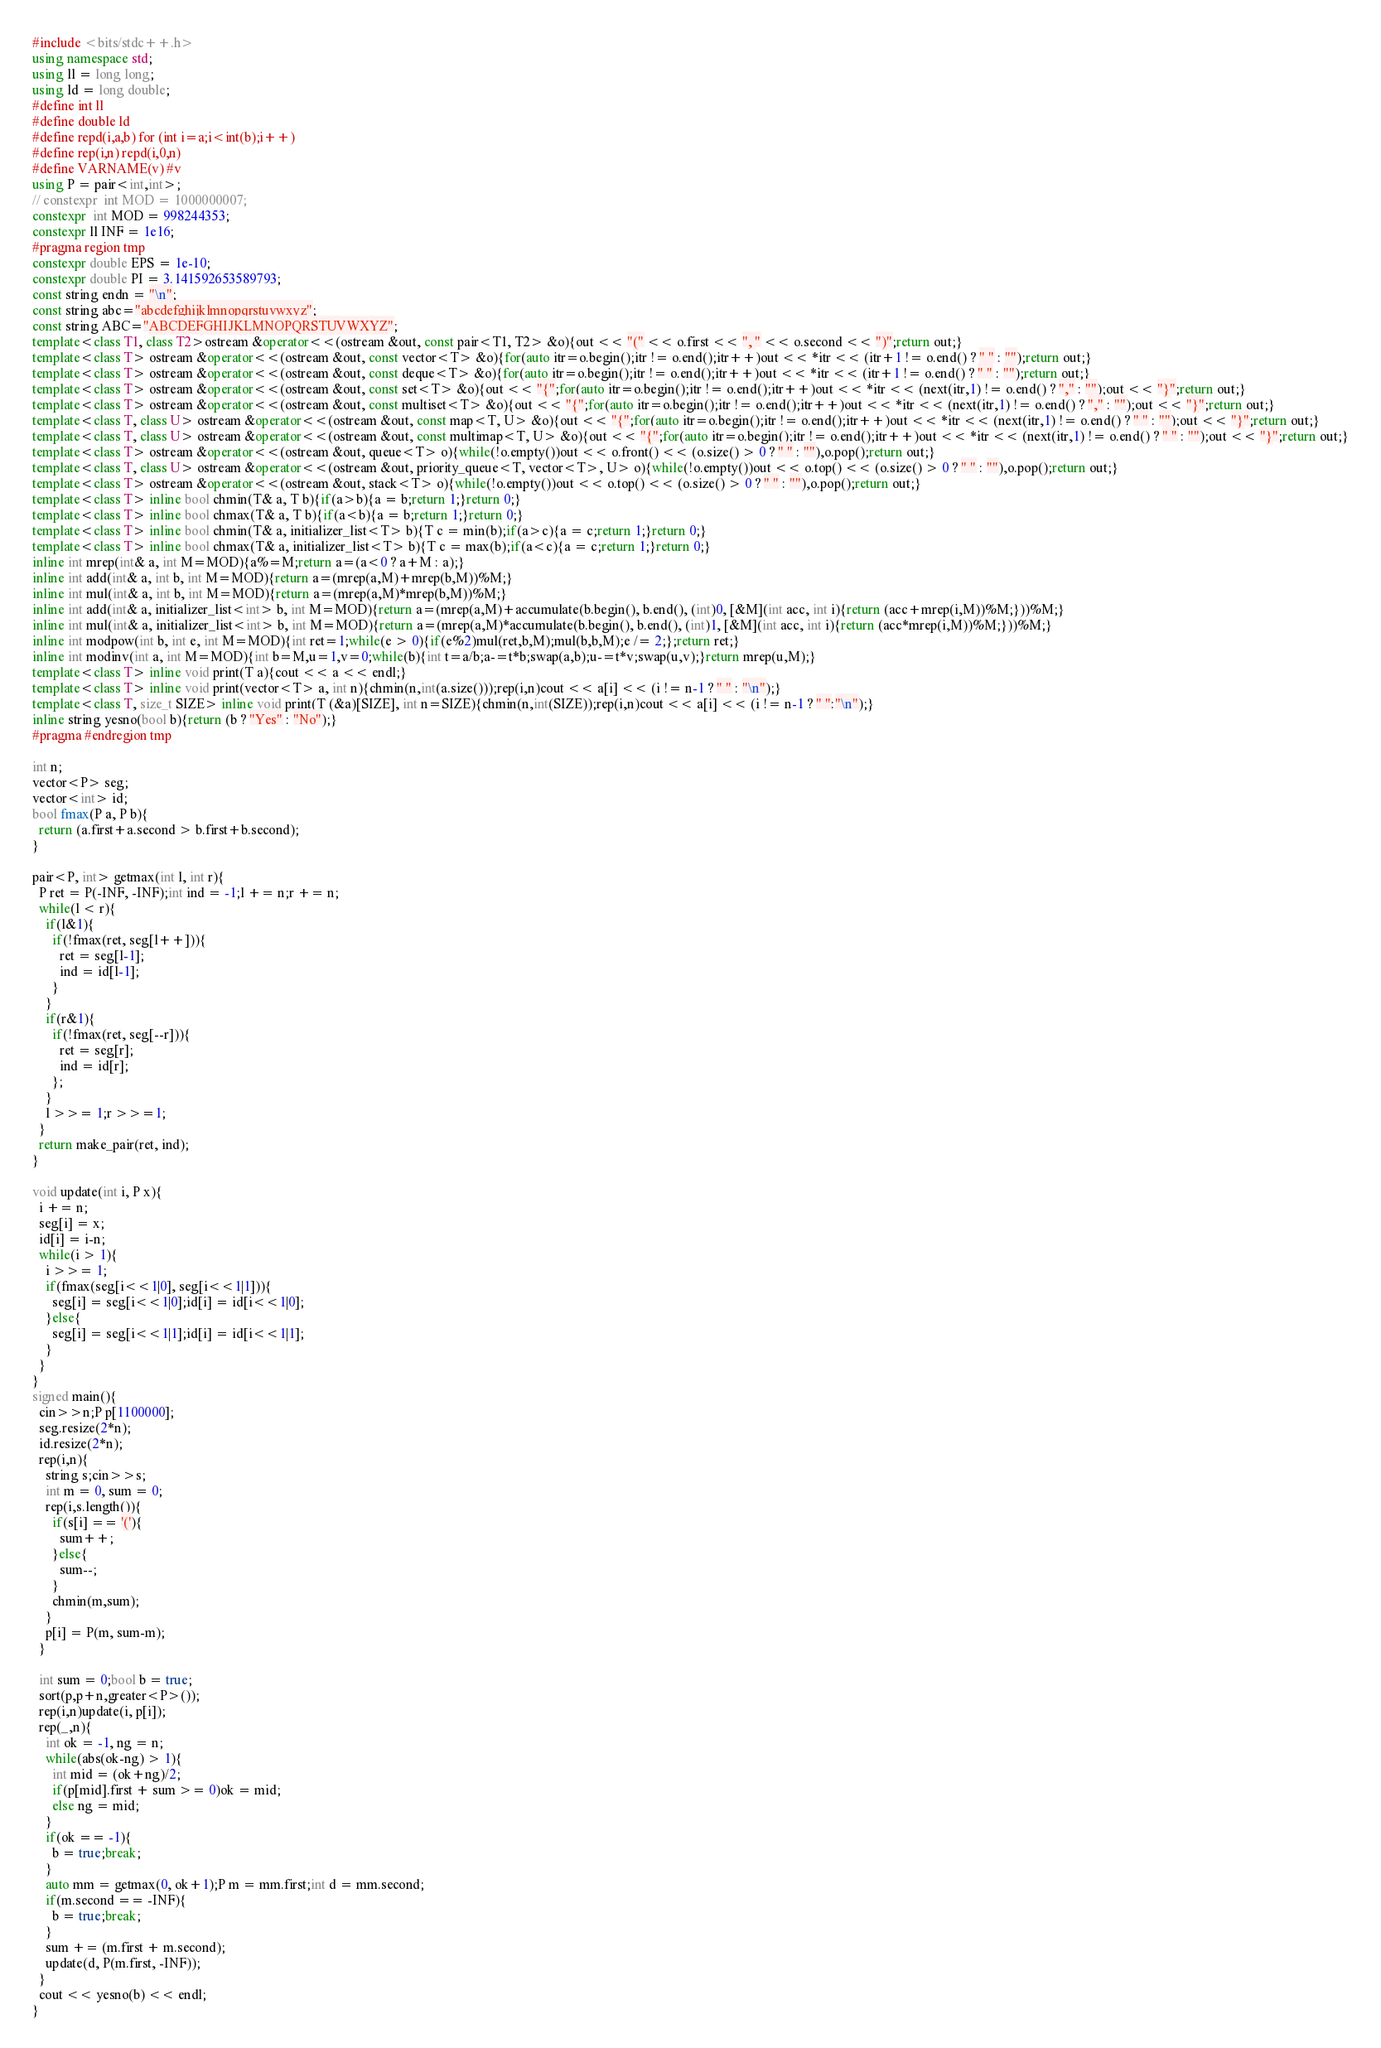<code> <loc_0><loc_0><loc_500><loc_500><_C++_>#include <bits/stdc++.h>
using namespace std;
using ll = long long;
using ld = long double;
#define int ll
#define double ld
#define repd(i,a,b) for (int i=a;i<int(b);i++)
#define rep(i,n) repd(i,0,n)
#define VARNAME(v) #v
using P = pair<int,int>;
// constexpr  int MOD = 1000000007;
constexpr  int MOD = 998244353;
constexpr ll INF = 1e16;
#pragma region tmp
constexpr double EPS = 1e-10;
constexpr double PI = 3.141592653589793;
const string endn = "\n";
const string abc="abcdefghijklmnopqrstuvwxyz";
const string ABC="ABCDEFGHIJKLMNOPQRSTUVWXYZ";
template<class T1, class T2>ostream &operator<<(ostream &out, const pair<T1, T2> &o){out << "(" << o.first << ", " << o.second << ")";return out;}
template<class T> ostream &operator<<(ostream &out, const vector<T> &o){for(auto itr=o.begin();itr != o.end();itr++)out << *itr << (itr+1 != o.end() ? " " : "");return out;}
template<class T> ostream &operator<<(ostream &out, const deque<T> &o){for(auto itr=o.begin();itr != o.end();itr++)out << *itr << (itr+1 != o.end() ? " " : "");return out;}
template<class T> ostream &operator<<(ostream &out, const set<T> &o){out << "{";for(auto itr=o.begin();itr != o.end();itr++)out << *itr << (next(itr,1) != o.end() ? "," : "");out << "}";return out;}
template<class T> ostream &operator<<(ostream &out, const multiset<T> &o){out << "{";for(auto itr=o.begin();itr != o.end();itr++)out << *itr << (next(itr,1) != o.end() ? "," : "");out << "}";return out;}
template<class T, class U> ostream &operator<<(ostream &out, const map<T, U> &o){out << "{";for(auto itr=o.begin();itr != o.end();itr++)out << *itr << (next(itr,1) != o.end() ? " " : "");out << "}";return out;}
template<class T, class U> ostream &operator<<(ostream &out, const multimap<T, U> &o){out << "{";for(auto itr=o.begin();itr != o.end();itr++)out << *itr << (next(itr,1) != o.end() ? " " : "");out << "}";return out;}
template<class T> ostream &operator<<(ostream &out, queue<T> o){while(!o.empty())out << o.front() << (o.size() > 0 ? " " : ""),o.pop();return out;}
template<class T, class U> ostream &operator<<(ostream &out, priority_queue<T, vector<T>, U> o){while(!o.empty())out << o.top() << (o.size() > 0 ? " " : ""),o.pop();return out;}
template<class T> ostream &operator<<(ostream &out, stack<T> o){while(!o.empty())out << o.top() << (o.size() > 0 ? " " : ""),o.pop();return out;}
template<class T> inline bool chmin(T& a, T b){if(a>b){a = b;return 1;}return 0;}
template<class T> inline bool chmax(T& a, T b){if(a<b){a = b;return 1;}return 0;}
template<class T> inline bool chmin(T& a, initializer_list<T> b){T c = min(b);if(a>c){a = c;return 1;}return 0;}
template<class T> inline bool chmax(T& a, initializer_list<T> b){T c = max(b);if(a<c){a = c;return 1;}return 0;}
inline int mrep(int& a, int M=MOD){a%=M;return a=(a<0 ? a+M : a);}
inline int add(int& a, int b, int M=MOD){return a=(mrep(a,M)+mrep(b,M))%M;}
inline int mul(int& a, int b, int M=MOD){return a=(mrep(a,M)*mrep(b,M))%M;}
inline int add(int& a, initializer_list<int> b, int M=MOD){return a=(mrep(a,M)+accumulate(b.begin(), b.end(), (int)0, [&M](int acc, int i){return (acc+mrep(i,M))%M;}))%M;}
inline int mul(int& a, initializer_list<int> b, int M=MOD){return a=(mrep(a,M)*accumulate(b.begin(), b.end(), (int)1, [&M](int acc, int i){return (acc*mrep(i,M))%M;}))%M;}
inline int modpow(int b, int e, int M=MOD){int ret=1;while(e > 0){if(e%2)mul(ret,b,M);mul(b,b,M);e /= 2;};return ret;}
inline int modinv(int a, int M=MOD){int b=M,u=1,v=0;while(b){int t=a/b;a-=t*b;swap(a,b);u-=t*v;swap(u,v);}return mrep(u,M);}
template<class T> inline void print(T a){cout << a << endl;}
template<class T> inline void print(vector<T> a, int n){chmin(n,int(a.size()));rep(i,n)cout << a[i] << (i != n-1 ? " " : "\n");}
template<class T, size_t SIZE> inline void print(T (&a)[SIZE], int n=SIZE){chmin(n,int(SIZE));rep(i,n)cout << a[i] << (i != n-1 ? " ":"\n");}
inline string yesno(bool b){return (b ? "Yes" : "No");}
#pragma #endregion tmp

int n;
vector<P> seg;
vector<int> id;
bool fmax(P a, P b){
  return (a.first+a.second > b.first+b.second);
}

pair<P, int> getmax(int l, int r){
  P ret = P(-INF, -INF);int ind = -1;l += n;r += n;
  while(l < r){
    if(l&1){
      if(!fmax(ret, seg[l++])){
        ret = seg[l-1];
        ind = id[l-1];
      }
    }
    if(r&1){
      if(!fmax(ret, seg[--r])){
        ret = seg[r];
        ind = id[r];
      };
    }
    l >>= 1;r >>=1;
  }
  return make_pair(ret, ind);
}

void update(int i, P x){
  i += n;
  seg[i] = x;
  id[i] = i-n;
  while(i > 1){
    i >>= 1;
    if(fmax(seg[i<<1|0], seg[i<<1|1])){
      seg[i] = seg[i<<1|0];id[i] = id[i<<1|0];
    }else{
      seg[i] = seg[i<<1|1];id[i] = id[i<<1|1];
    }
  }
}
signed main(){
  cin>>n;P p[1100000];
  seg.resize(2*n);
  id.resize(2*n);
  rep(i,n){
    string s;cin>>s;
    int m = 0, sum = 0;
    rep(i,s.length()){
      if(s[i] == '('){
        sum++;
      }else{
        sum--;
      }
      chmin(m,sum);
    }
    p[i] = P(m, sum-m);
  }
  
  int sum = 0;bool b = true;
  sort(p,p+n,greater<P>());
  rep(i,n)update(i, p[i]);
  rep(_,n){
    int ok = -1, ng = n;
    while(abs(ok-ng) > 1){
      int mid = (ok+ng)/2;
      if(p[mid].first + sum >= 0)ok = mid;
      else ng = mid;
    }
    if(ok == -1){
      b = true;break;
    }
    auto mm = getmax(0, ok+1);P m = mm.first;int d = mm.second;
    if(m.second == -INF){
      b = true;break;
    }
    sum += (m.first + m.second);
    update(d, P(m.first, -INF));
  }
  cout << yesno(b) << endl;
}
</code> 